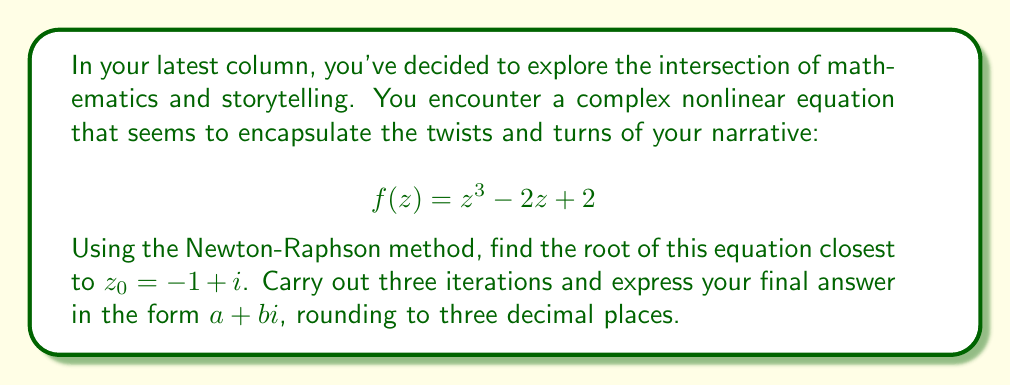What is the answer to this math problem? The Newton-Raphson method for complex functions is given by:

$$z_{n+1} = z_n - \frac{f(z_n)}{f'(z_n)}$$

Where $f'(z) = 3z^2 - 2$ for our given function.

Starting with $z_0 = -1 + i$:

Iteration 1:
$$f(z_0) = (-1+i)^3 - 2(-1+i) + 2 = -4 - i$$
$$f'(z_0) = 3(-1+i)^2 - 2 = 1 - 6i$$

$$z_1 = (-1+i) - \frac{-4-i}{1-6i} \cdot \frac{1+6i}{1+6i} = -0.5439 + 0.7683i$$

Iteration 2:
$$f(z_1) = (-0.5439 + 0.7683i)^3 - 2(-0.5439 + 0.7683i) + 2 = 0.1893 - 0.5212i$$
$$f'(z_1) = 3(-0.5439 + 0.7683i)^2 - 2 = -2.4180 - 2.5104i$$

$$z_2 = (-0.5439 + 0.7683i) - \frac{0.1893 - 0.5212i}{-2.4180 - 2.5104i} \cdot \frac{-2.4180 + 2.5104i}{-2.4180 + 2.5104i} = -0.4666 + 0.8850i$$

Iteration 3:
$$f(z_2) = (-0.4666 + 0.8850i)^3 - 2(-0.4666 + 0.8850i) + 2 = 0.0046 - 0.0088i$$
$$f'(z_2) = 3(-0.4666 + 0.8850i)^2 - 2 = -2.9415 - 2.4735i$$

$$z_3 = (-0.4666 + 0.8850i) - \frac{0.0046 - 0.0088i}{-2.9415 - 2.4735i} \cdot \frac{-2.9415 + 2.4735i}{-2.9415 + 2.4735i} = -0.4668 + 0.8844i$$

Rounding to three decimal places gives the final answer.
Answer: $-0.467 + 0.884i$ 